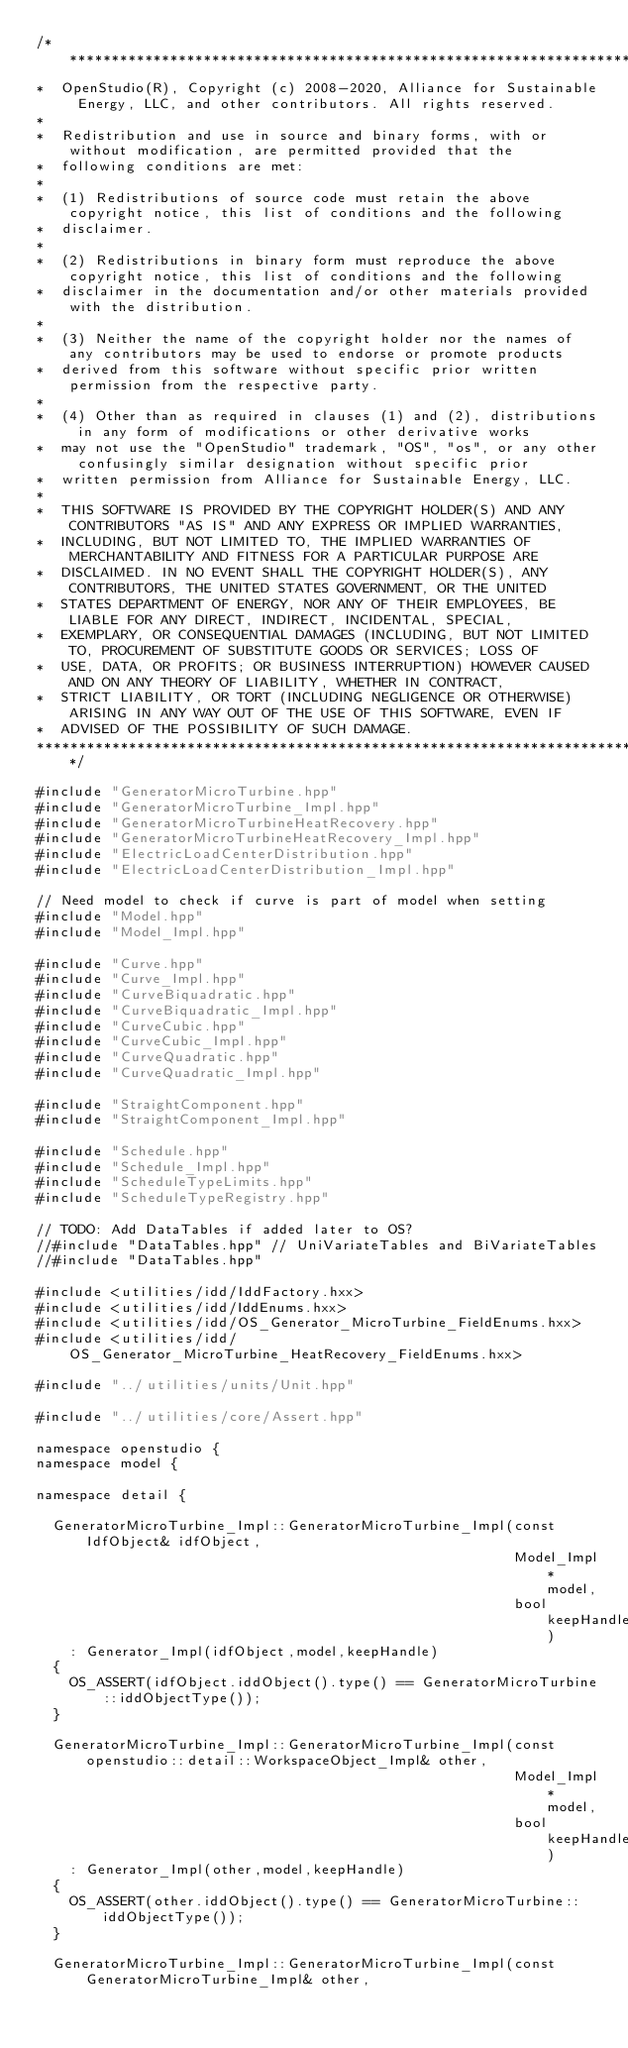<code> <loc_0><loc_0><loc_500><loc_500><_C++_>/***********************************************************************************************************************
*  OpenStudio(R), Copyright (c) 2008-2020, Alliance for Sustainable Energy, LLC, and other contributors. All rights reserved.
*
*  Redistribution and use in source and binary forms, with or without modification, are permitted provided that the
*  following conditions are met:
*
*  (1) Redistributions of source code must retain the above copyright notice, this list of conditions and the following
*  disclaimer.
*
*  (2) Redistributions in binary form must reproduce the above copyright notice, this list of conditions and the following
*  disclaimer in the documentation and/or other materials provided with the distribution.
*
*  (3) Neither the name of the copyright holder nor the names of any contributors may be used to endorse or promote products
*  derived from this software without specific prior written permission from the respective party.
*
*  (4) Other than as required in clauses (1) and (2), distributions in any form of modifications or other derivative works
*  may not use the "OpenStudio" trademark, "OS", "os", or any other confusingly similar designation without specific prior
*  written permission from Alliance for Sustainable Energy, LLC.
*
*  THIS SOFTWARE IS PROVIDED BY THE COPYRIGHT HOLDER(S) AND ANY CONTRIBUTORS "AS IS" AND ANY EXPRESS OR IMPLIED WARRANTIES,
*  INCLUDING, BUT NOT LIMITED TO, THE IMPLIED WARRANTIES OF MERCHANTABILITY AND FITNESS FOR A PARTICULAR PURPOSE ARE
*  DISCLAIMED. IN NO EVENT SHALL THE COPYRIGHT HOLDER(S), ANY CONTRIBUTORS, THE UNITED STATES GOVERNMENT, OR THE UNITED
*  STATES DEPARTMENT OF ENERGY, NOR ANY OF THEIR EMPLOYEES, BE LIABLE FOR ANY DIRECT, INDIRECT, INCIDENTAL, SPECIAL,
*  EXEMPLARY, OR CONSEQUENTIAL DAMAGES (INCLUDING, BUT NOT LIMITED TO, PROCUREMENT OF SUBSTITUTE GOODS OR SERVICES; LOSS OF
*  USE, DATA, OR PROFITS; OR BUSINESS INTERRUPTION) HOWEVER CAUSED AND ON ANY THEORY OF LIABILITY, WHETHER IN CONTRACT,
*  STRICT LIABILITY, OR TORT (INCLUDING NEGLIGENCE OR OTHERWISE) ARISING IN ANY WAY OUT OF THE USE OF THIS SOFTWARE, EVEN IF
*  ADVISED OF THE POSSIBILITY OF SUCH DAMAGE.
***********************************************************************************************************************/

#include "GeneratorMicroTurbine.hpp"
#include "GeneratorMicroTurbine_Impl.hpp"
#include "GeneratorMicroTurbineHeatRecovery.hpp"
#include "GeneratorMicroTurbineHeatRecovery_Impl.hpp"
#include "ElectricLoadCenterDistribution.hpp"
#include "ElectricLoadCenterDistribution_Impl.hpp"

// Need model to check if curve is part of model when setting
#include "Model.hpp"
#include "Model_Impl.hpp"

#include "Curve.hpp"
#include "Curve_Impl.hpp"
#include "CurveBiquadratic.hpp"
#include "CurveBiquadratic_Impl.hpp"
#include "CurveCubic.hpp"
#include "CurveCubic_Impl.hpp"
#include "CurveQuadratic.hpp"
#include "CurveQuadratic_Impl.hpp"

#include "StraightComponent.hpp"
#include "StraightComponent_Impl.hpp"

#include "Schedule.hpp"
#include "Schedule_Impl.hpp"
#include "ScheduleTypeLimits.hpp"
#include "ScheduleTypeRegistry.hpp"

// TODO: Add DataTables if added later to OS?
//#include "DataTables.hpp" // UniVariateTables and BiVariateTables
//#include "DataTables.hpp"

#include <utilities/idd/IddFactory.hxx>
#include <utilities/idd/IddEnums.hxx>
#include <utilities/idd/OS_Generator_MicroTurbine_FieldEnums.hxx>
#include <utilities/idd/OS_Generator_MicroTurbine_HeatRecovery_FieldEnums.hxx>

#include "../utilities/units/Unit.hpp"

#include "../utilities/core/Assert.hpp"

namespace openstudio {
namespace model {

namespace detail {

  GeneratorMicroTurbine_Impl::GeneratorMicroTurbine_Impl(const IdfObject& idfObject,
                                                         Model_Impl* model,
                                                         bool keepHandle)
    : Generator_Impl(idfObject,model,keepHandle)
  {
    OS_ASSERT(idfObject.iddObject().type() == GeneratorMicroTurbine::iddObjectType());
  }

  GeneratorMicroTurbine_Impl::GeneratorMicroTurbine_Impl(const openstudio::detail::WorkspaceObject_Impl& other,
                                                         Model_Impl* model,
                                                         bool keepHandle)
    : Generator_Impl(other,model,keepHandle)
  {
    OS_ASSERT(other.iddObject().type() == GeneratorMicroTurbine::iddObjectType());
  }

  GeneratorMicroTurbine_Impl::GeneratorMicroTurbine_Impl(const GeneratorMicroTurbine_Impl& other,</code> 